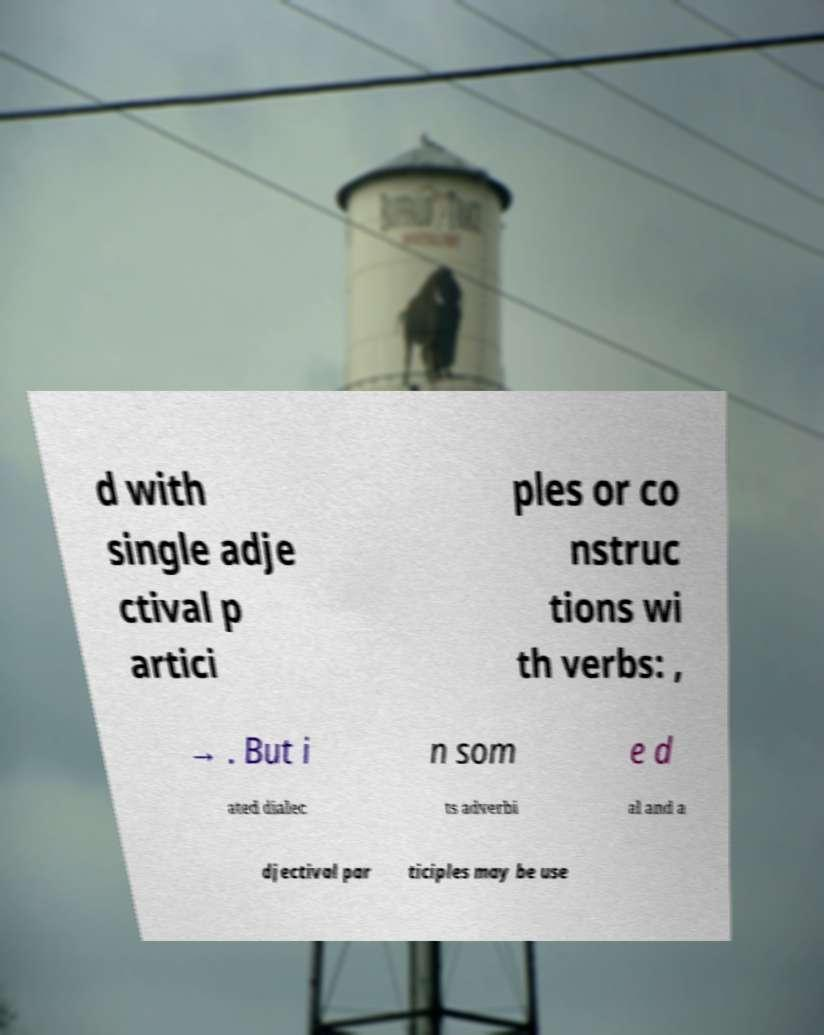Please read and relay the text visible in this image. What does it say? d with single adje ctival p artici ples or co nstruc tions wi th verbs: , → . But i n som e d ated dialec ts adverbi al and a djectival par ticiples may be use 